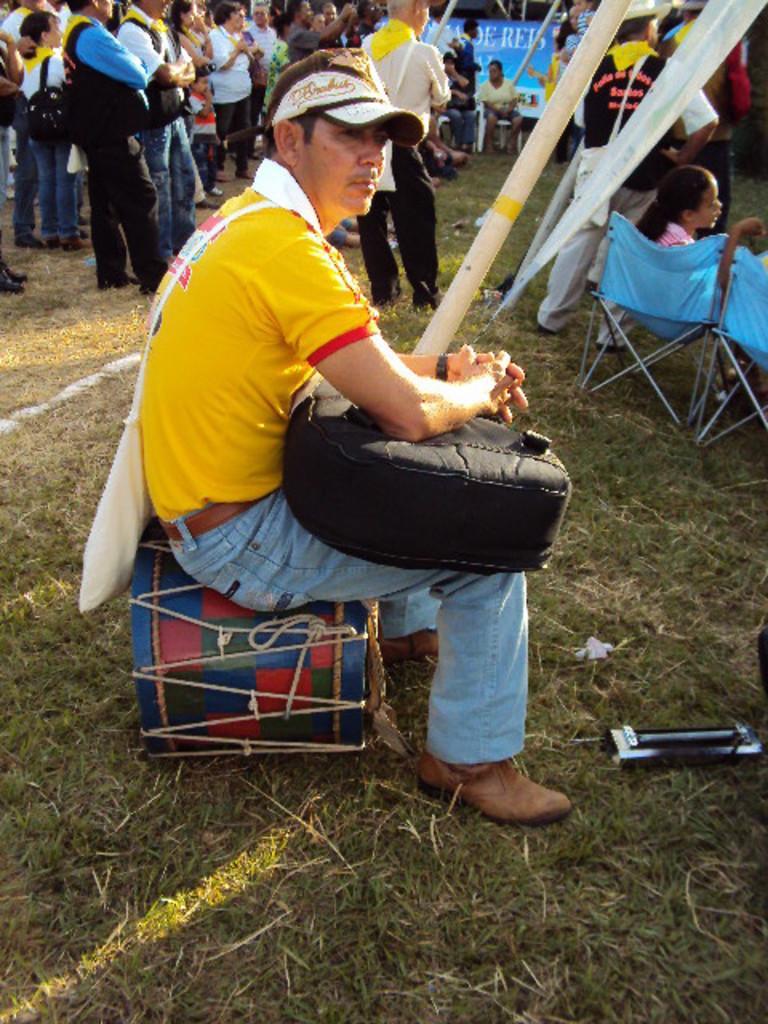Can you describe this image briefly? In this image there is a person with a bag is sitting on the drum, and there are group of people sitting on the chairs , there are group of people standing, and there is a banner and some other objects. 